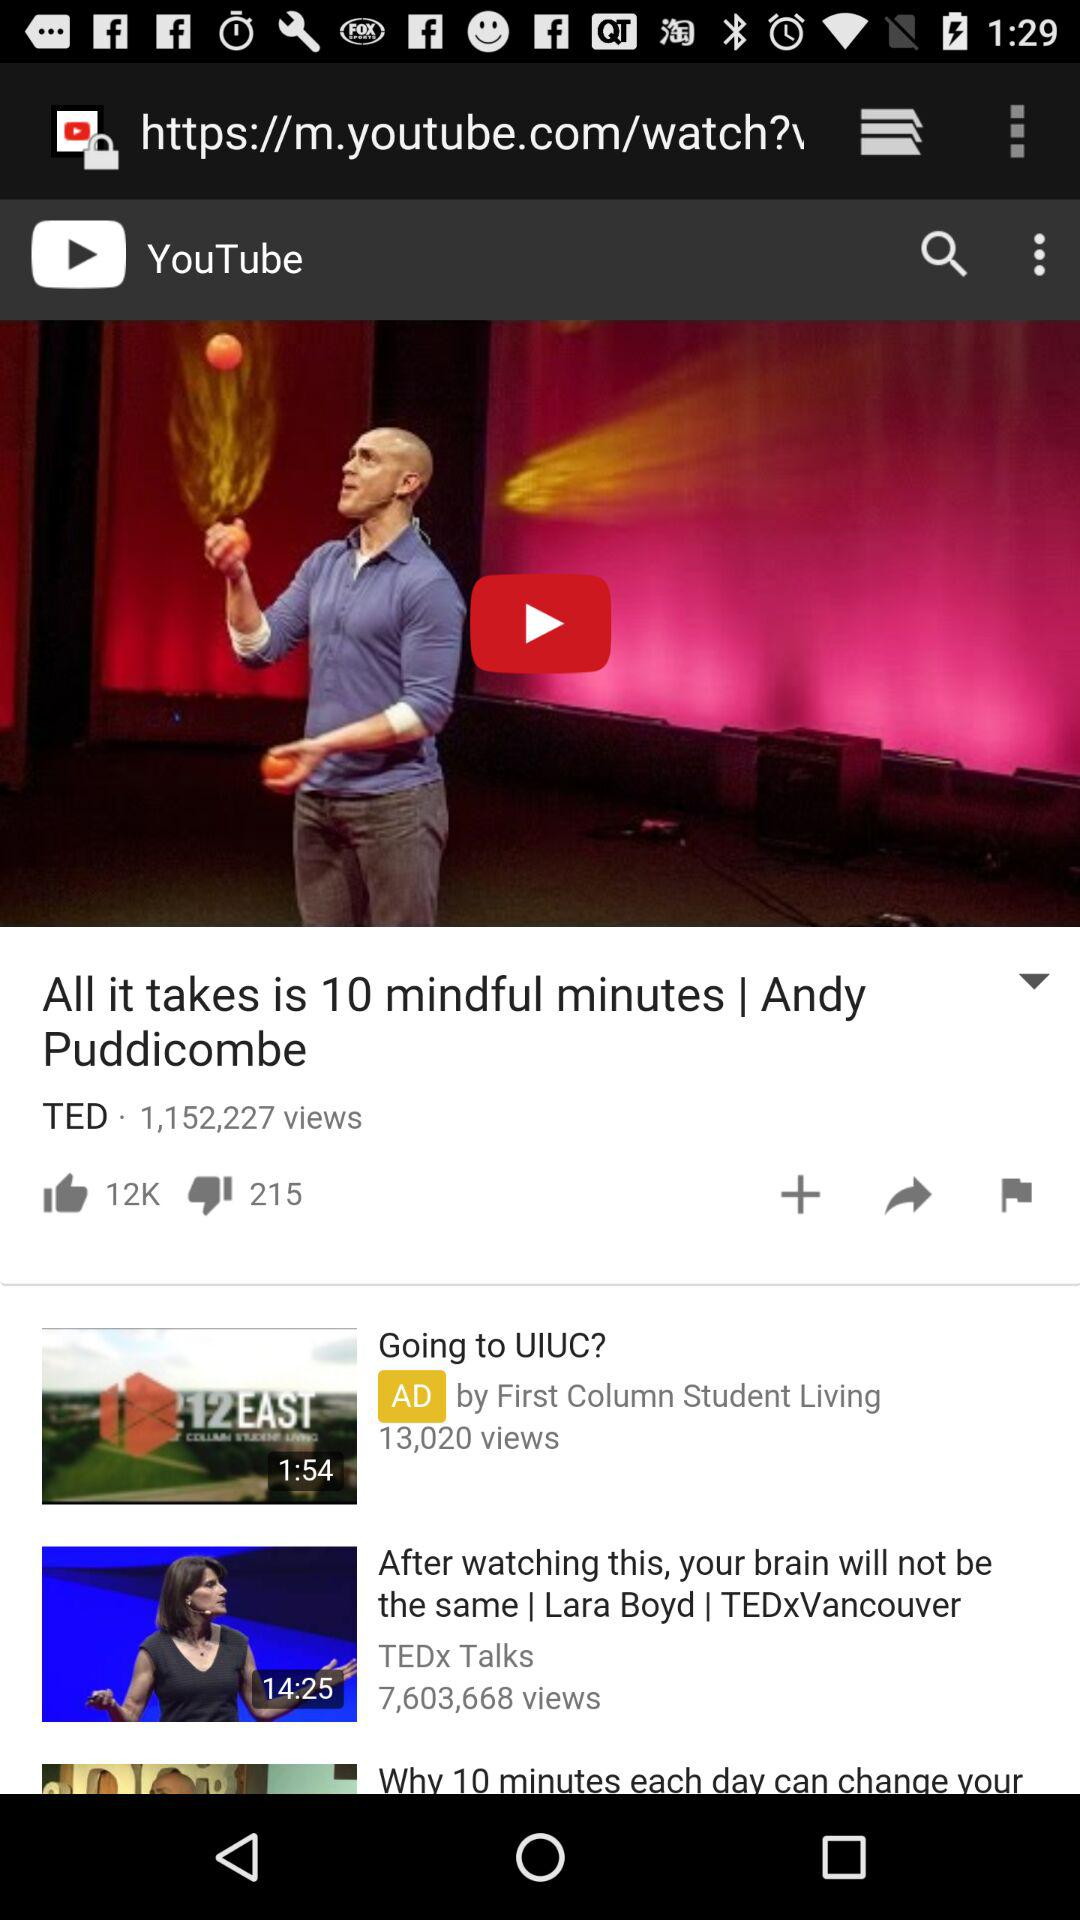How many dislikes in total are there on the video "All it takes is 10 mindful minutes"? There are 215 dislikes on the video. 